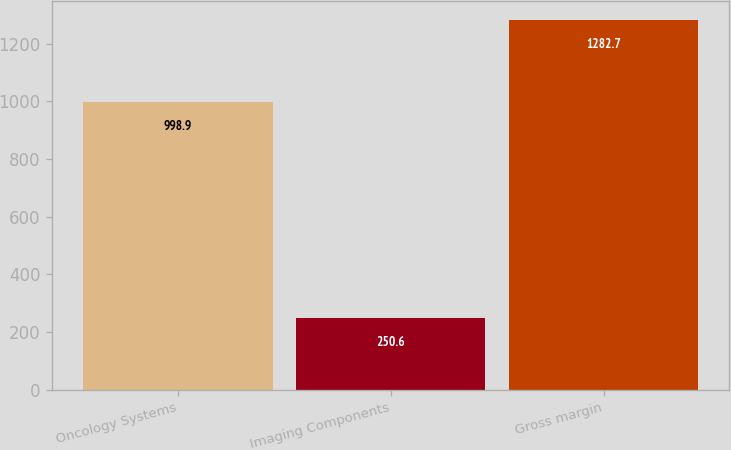Convert chart to OTSL. <chart><loc_0><loc_0><loc_500><loc_500><bar_chart><fcel>Oncology Systems<fcel>Imaging Components<fcel>Gross margin<nl><fcel>998.9<fcel>250.6<fcel>1282.7<nl></chart> 